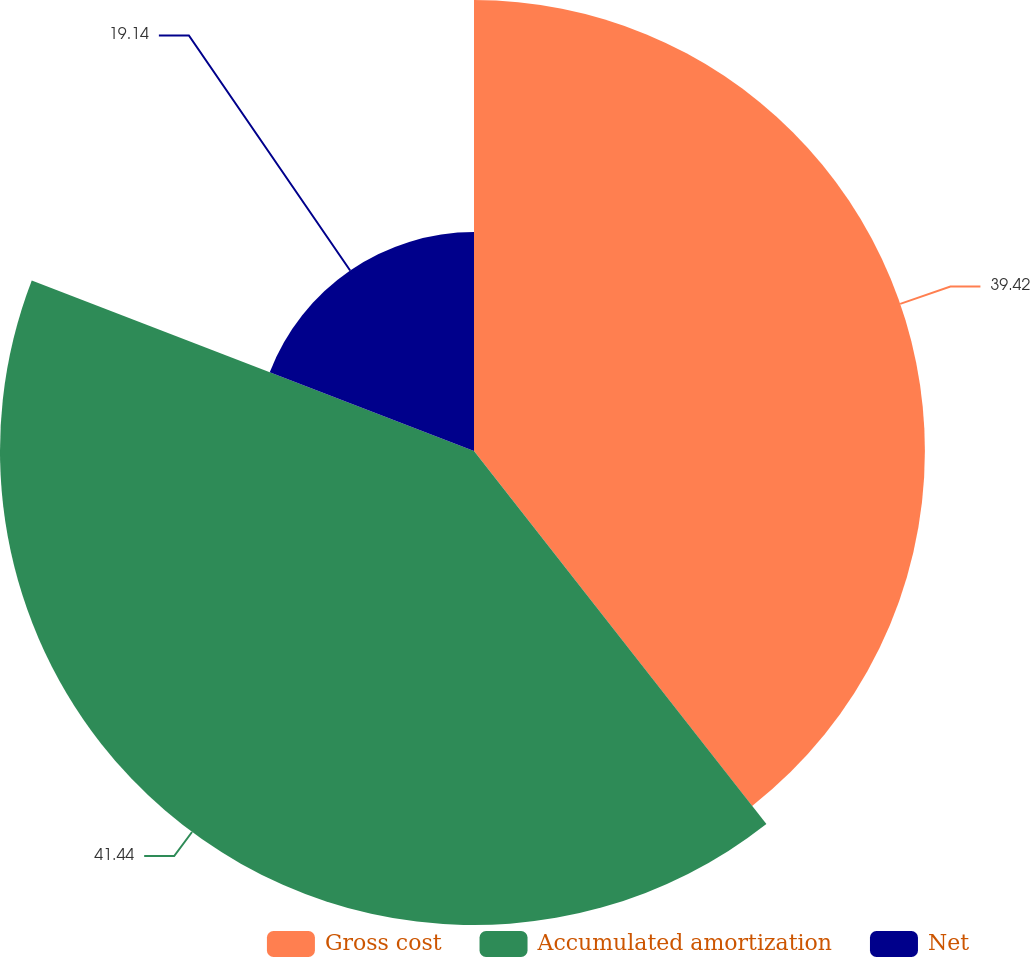Convert chart. <chart><loc_0><loc_0><loc_500><loc_500><pie_chart><fcel>Gross cost<fcel>Accumulated amortization<fcel>Net<nl><fcel>39.42%<fcel>41.44%<fcel>19.14%<nl></chart> 